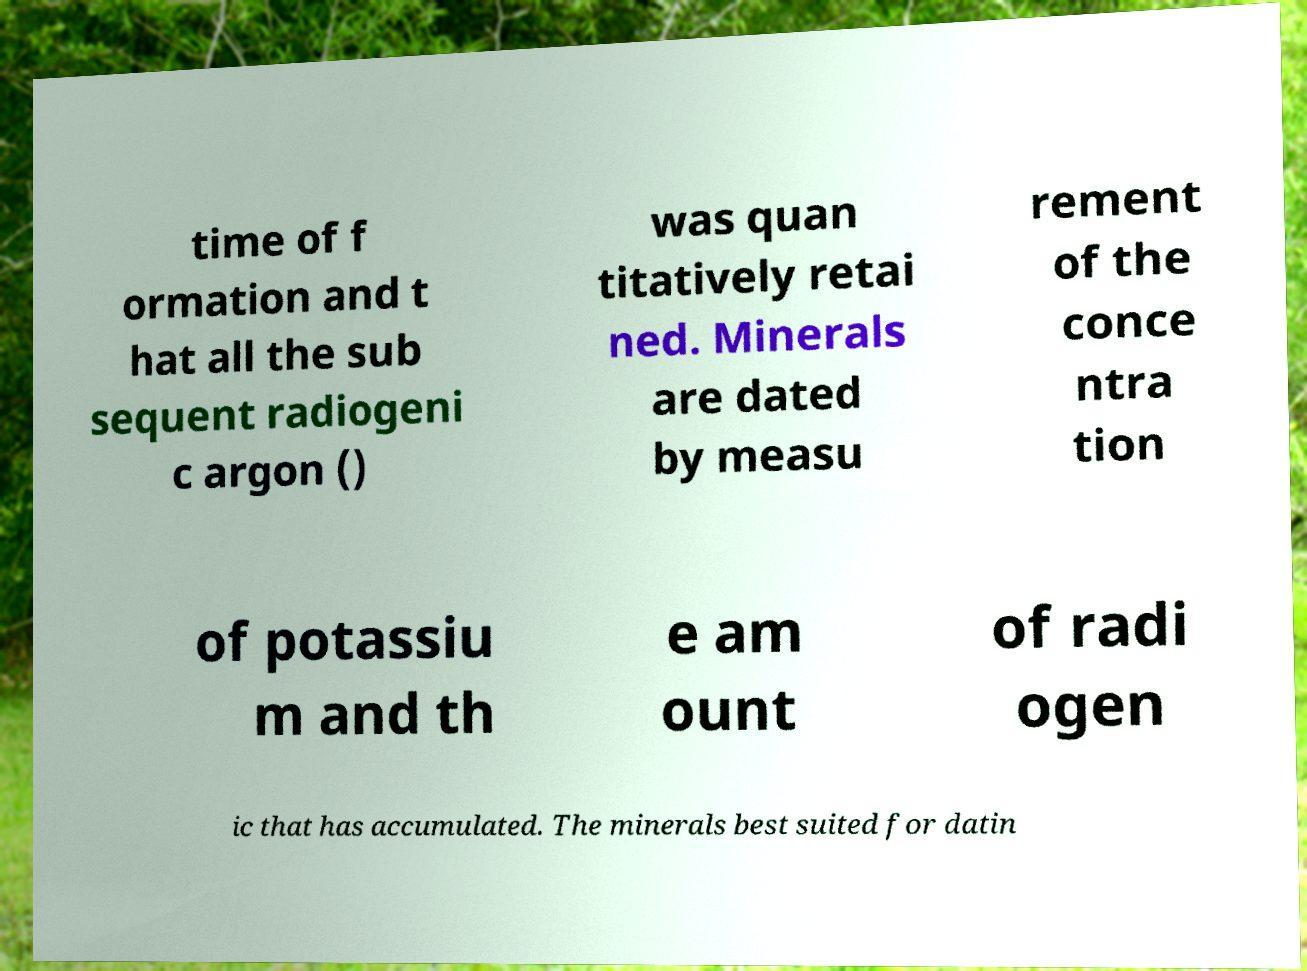What messages or text are displayed in this image? I need them in a readable, typed format. time of f ormation and t hat all the sub sequent radiogeni c argon () was quan titatively retai ned. Minerals are dated by measu rement of the conce ntra tion of potassiu m and th e am ount of radi ogen ic that has accumulated. The minerals best suited for datin 